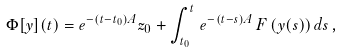Convert formula to latex. <formula><loc_0><loc_0><loc_500><loc_500>\Phi [ y ] ( t ) = e ^ { - ( t - t _ { 0 } ) A } z _ { 0 } + \int _ { t _ { 0 } } ^ { t } \, e ^ { - \left ( t - s \right ) A } \, F \left ( y ( s \right ) ) \, d s \, ,</formula> 